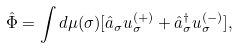Convert formula to latex. <formula><loc_0><loc_0><loc_500><loc_500>\hat { \Phi } = \int d \mu ( \sigma ) [ \hat { a } _ { \sigma } u _ { \sigma } ^ { ( + ) } + \hat { a } _ { \sigma } ^ { \dagger } u _ { \sigma } ^ { ( - ) } ] ,</formula> 